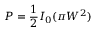Convert formula to latex. <formula><loc_0><loc_0><loc_500><loc_500>P = \frac { 1 } { 2 } I _ { 0 } ( \pi W ^ { 2 } )</formula> 